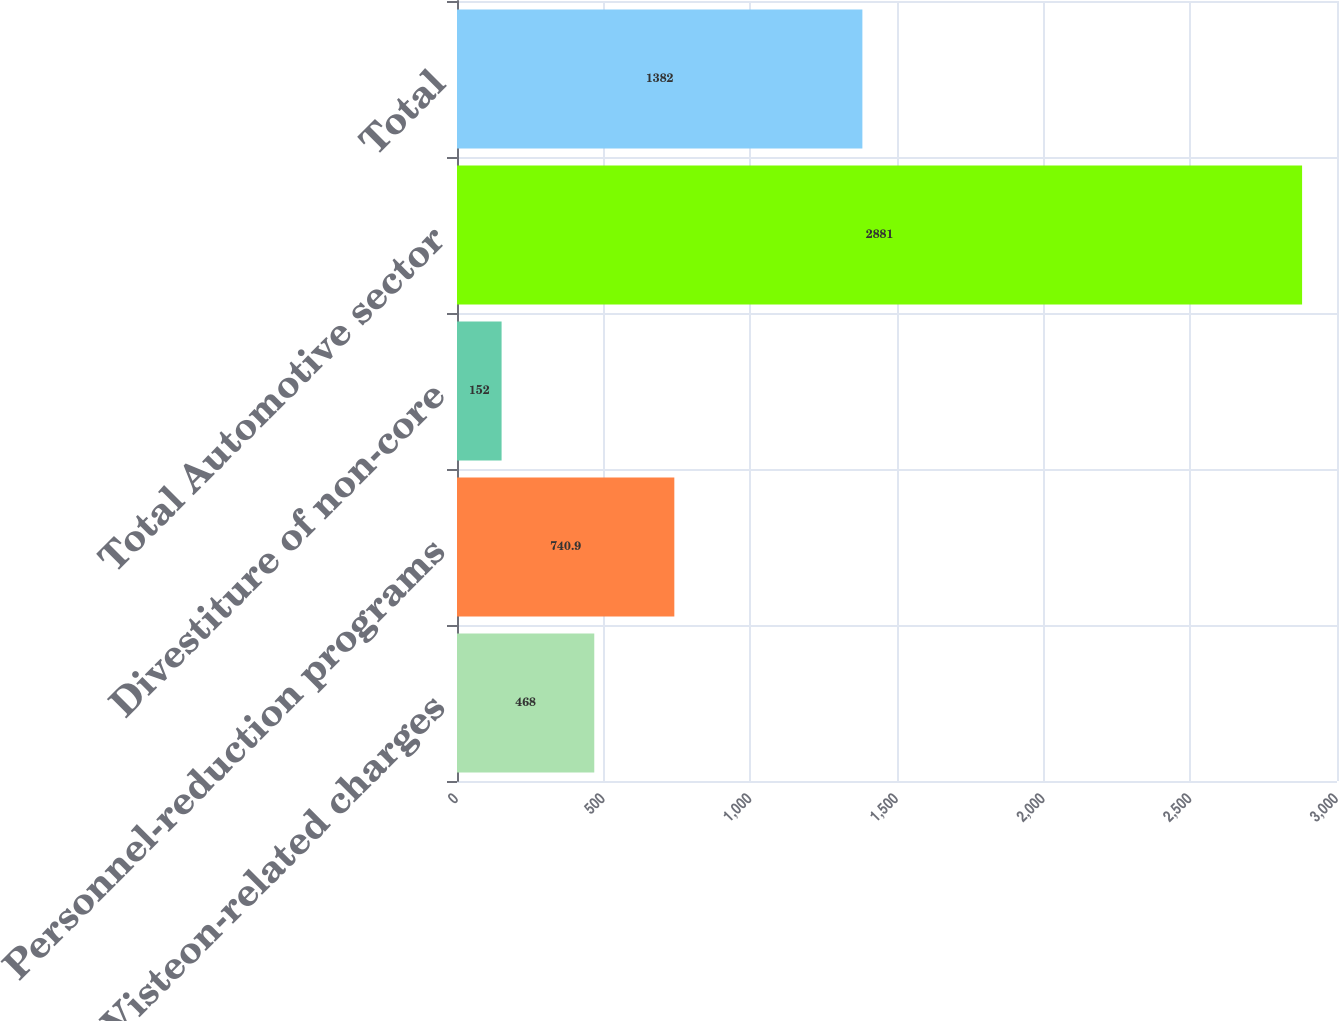<chart> <loc_0><loc_0><loc_500><loc_500><bar_chart><fcel>Visteon-related charges<fcel>Personnel-reduction programs<fcel>Divestiture of non-core<fcel>Total Automotive sector<fcel>Total<nl><fcel>468<fcel>740.9<fcel>152<fcel>2881<fcel>1382<nl></chart> 